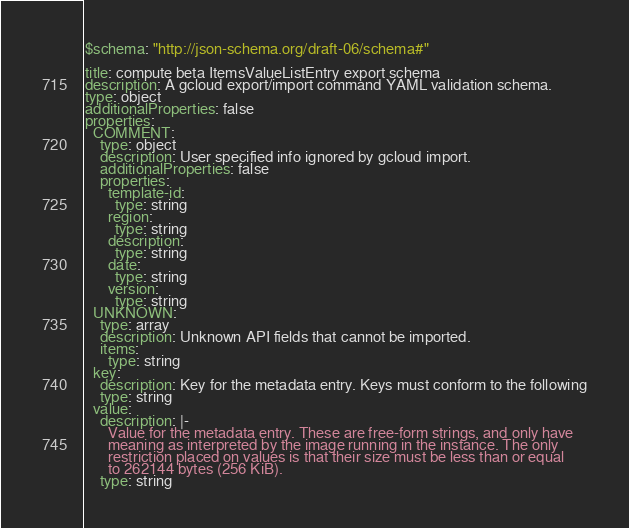Convert code to text. <code><loc_0><loc_0><loc_500><loc_500><_YAML_>$schema: "http://json-schema.org/draft-06/schema#"

title: compute beta ItemsValueListEntry export schema
description: A gcloud export/import command YAML validation schema.
type: object
additionalProperties: false
properties:
  COMMENT:
    type: object
    description: User specified info ignored by gcloud import.
    additionalProperties: false
    properties:
      template-id:
        type: string
      region:
        type: string
      description:
        type: string
      date:
        type: string
      version:
        type: string
  UNKNOWN:
    type: array
    description: Unknown API fields that cannot be imported.
    items:
      type: string
  key:
    description: Key for the metadata entry. Keys must conform to the following
    type: string
  value:
    description: |-
      Value for the metadata entry. These are free-form strings, and only have
      meaning as interpreted by the image running in the instance. The only
      restriction placed on values is that their size must be less than or equal
      to 262144 bytes (256 KiB).
    type: string
</code> 